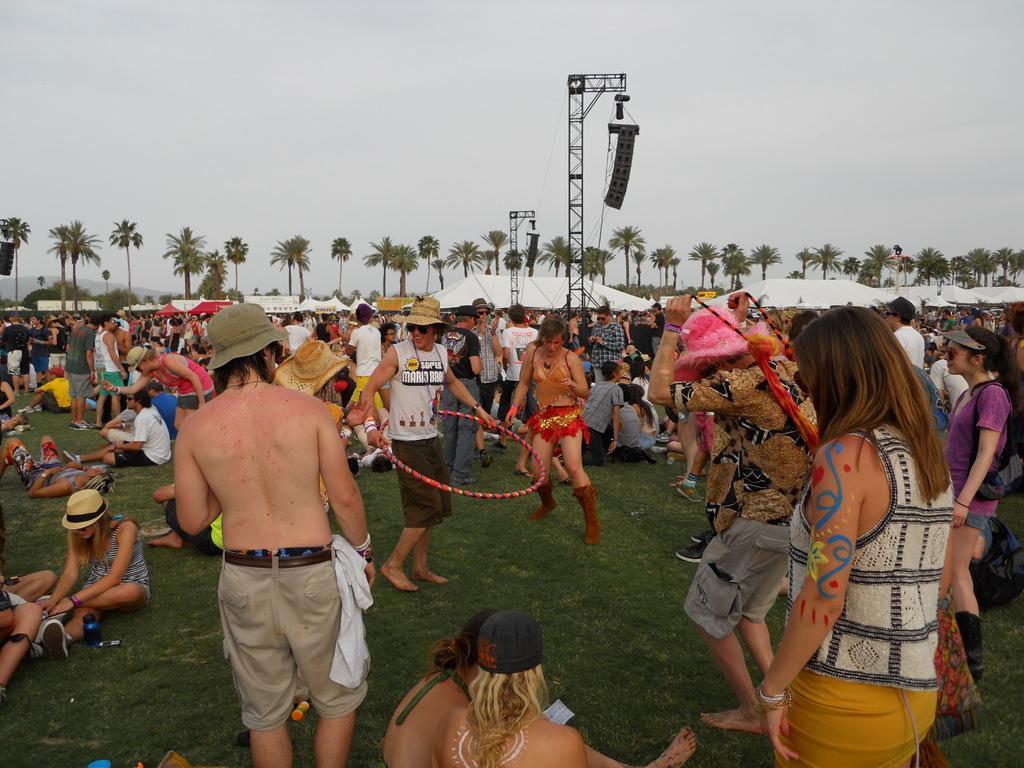Describe this image in one or two sentences. In the foreground of this image, there are people standing and sitting on the grass. In the middle, there is a man standing and holding a circular ring. In the background, there are tents, few pole like structures, trees and the sky. 